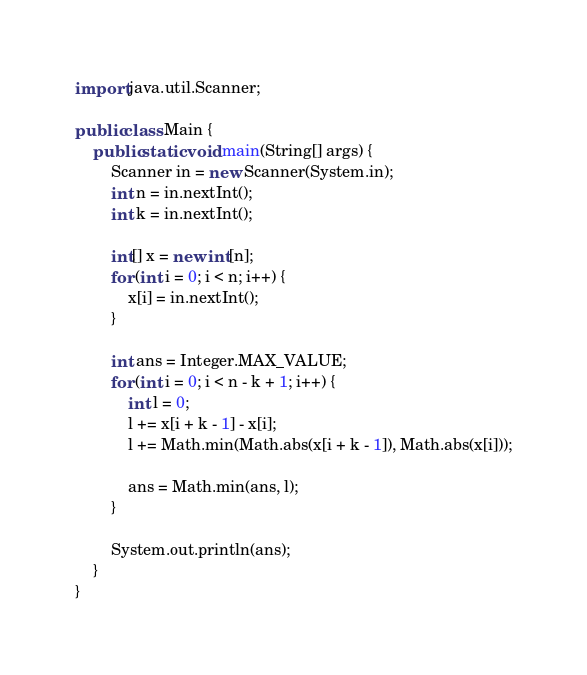Convert code to text. <code><loc_0><loc_0><loc_500><loc_500><_Java_>import java.util.Scanner;

public class Main {
    public static void main(String[] args) {
        Scanner in = new Scanner(System.in);
        int n = in.nextInt();
        int k = in.nextInt();

        int[] x = new int[n];
        for (int i = 0; i < n; i++) {
            x[i] = in.nextInt();
        }

        int ans = Integer.MAX_VALUE;
        for (int i = 0; i < n - k + 1; i++) {
            int l = 0;
            l += x[i + k - 1] - x[i];
            l += Math.min(Math.abs(x[i + k - 1]), Math.abs(x[i]));

            ans = Math.min(ans, l);
        }

        System.out.println(ans);
    }
}</code> 